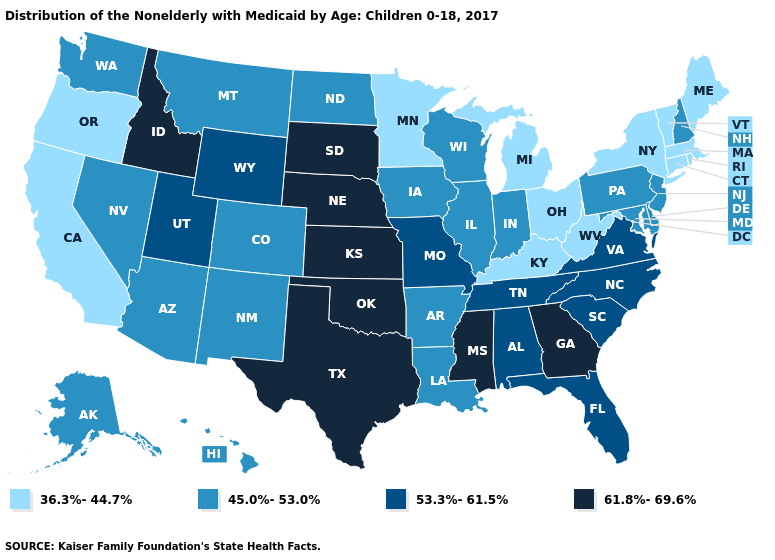What is the value of New York?
Give a very brief answer. 36.3%-44.7%. Among the states that border North Carolina , which have the lowest value?
Quick response, please. South Carolina, Tennessee, Virginia. Does the first symbol in the legend represent the smallest category?
Concise answer only. Yes. How many symbols are there in the legend?
Short answer required. 4. Name the states that have a value in the range 53.3%-61.5%?
Give a very brief answer. Alabama, Florida, Missouri, North Carolina, South Carolina, Tennessee, Utah, Virginia, Wyoming. Which states have the lowest value in the USA?
Be succinct. California, Connecticut, Kentucky, Maine, Massachusetts, Michigan, Minnesota, New York, Ohio, Oregon, Rhode Island, Vermont, West Virginia. Among the states that border Washington , does Idaho have the highest value?
Give a very brief answer. Yes. Name the states that have a value in the range 53.3%-61.5%?
Write a very short answer. Alabama, Florida, Missouri, North Carolina, South Carolina, Tennessee, Utah, Virginia, Wyoming. Which states have the lowest value in the Northeast?
Answer briefly. Connecticut, Maine, Massachusetts, New York, Rhode Island, Vermont. Does Massachusetts have the lowest value in the USA?
Write a very short answer. Yes. Which states hav the highest value in the MidWest?
Write a very short answer. Kansas, Nebraska, South Dakota. What is the value of Montana?
Quick response, please. 45.0%-53.0%. What is the highest value in the USA?
Answer briefly. 61.8%-69.6%. Among the states that border New Hampshire , which have the lowest value?
Give a very brief answer. Maine, Massachusetts, Vermont. Name the states that have a value in the range 61.8%-69.6%?
Be succinct. Georgia, Idaho, Kansas, Mississippi, Nebraska, Oklahoma, South Dakota, Texas. 